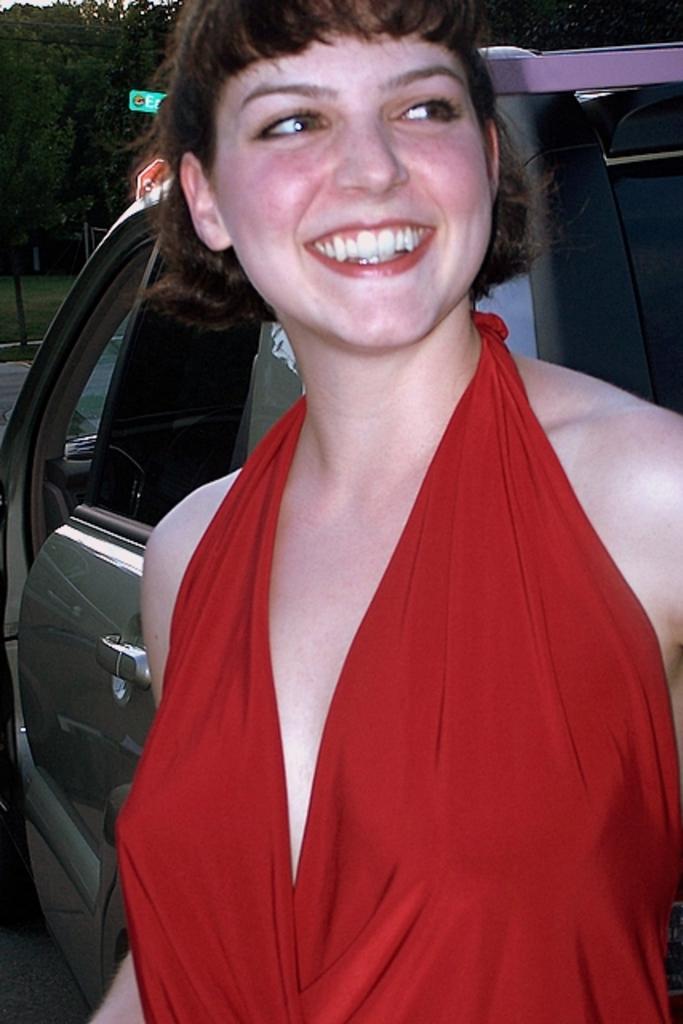How would you summarize this image in a sentence or two? In this image we can see a woman standing and smiling, behind her, we can see a vehicle, there are some trees, grass and poles. 